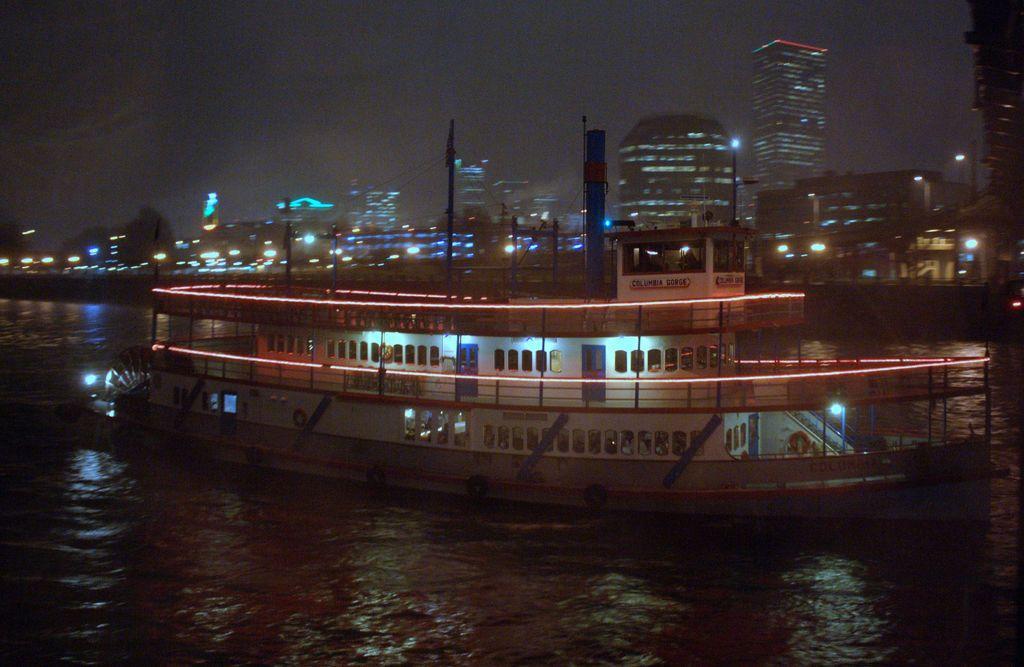How would you summarize this image in a sentence or two? In this image we can see ship on the water, electric lights, poles, towers, buildings, bridge, skyscraper, street lights, trees and sky. 